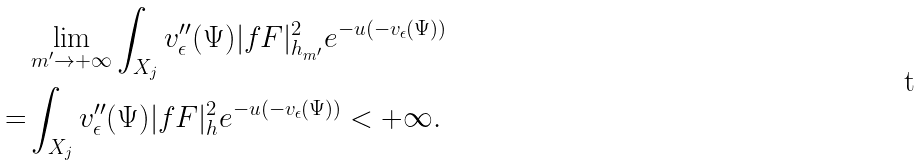<formula> <loc_0><loc_0><loc_500><loc_500>& \lim _ { m ^ { \prime } \to + \infty } \int _ { X _ { j } } v ^ { \prime \prime } _ { \epsilon } ( \Psi ) | f F | ^ { 2 } _ { h _ { m ^ { \prime } } } e ^ { - u ( - v _ { \epsilon } ( \Psi ) ) } \\ = & \int _ { X _ { j } } v ^ { \prime \prime } _ { \epsilon } ( \Psi ) | f F | ^ { 2 } _ { h } e ^ { - u ( - v _ { \epsilon } ( \Psi ) ) } < + \infty .</formula> 